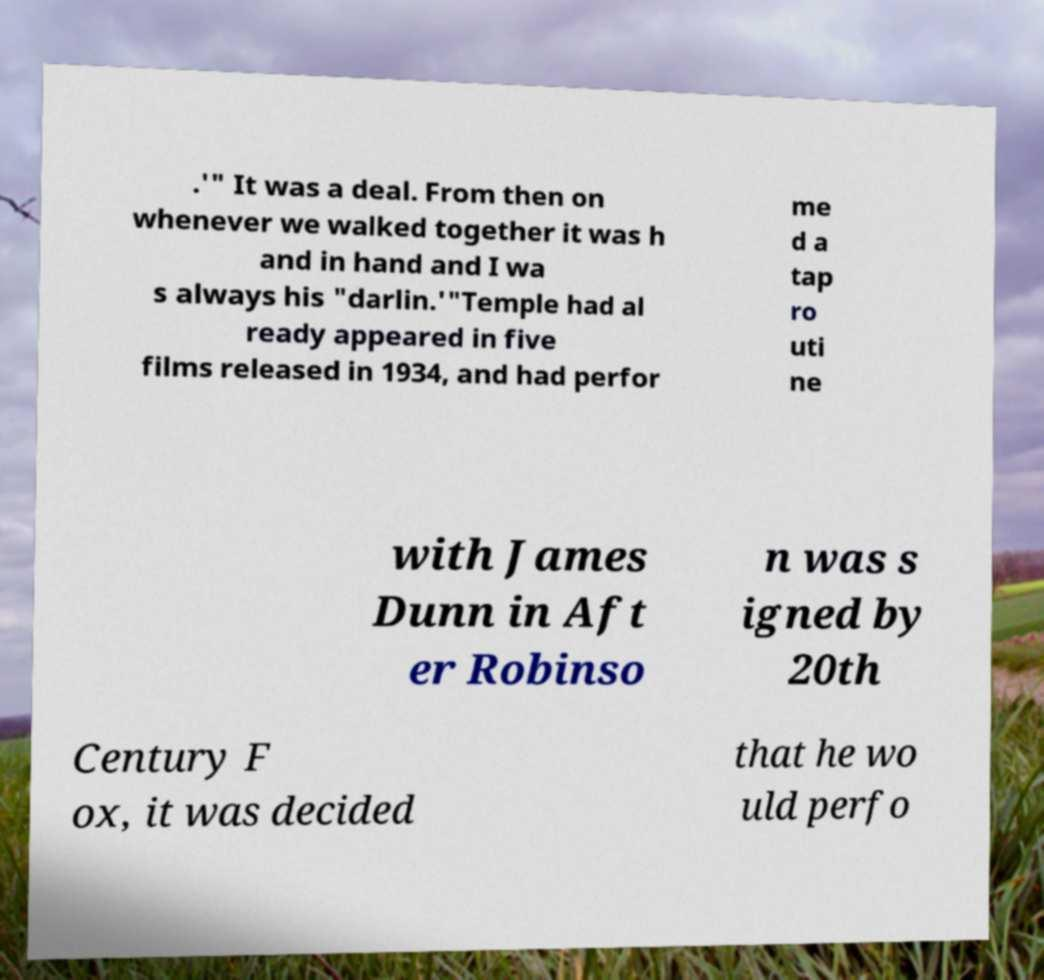There's text embedded in this image that I need extracted. Can you transcribe it verbatim? .'" It was a deal. From then on whenever we walked together it was h and in hand and I wa s always his "darlin.'"Temple had al ready appeared in five films released in 1934, and had perfor me d a tap ro uti ne with James Dunn in Aft er Robinso n was s igned by 20th Century F ox, it was decided that he wo uld perfo 